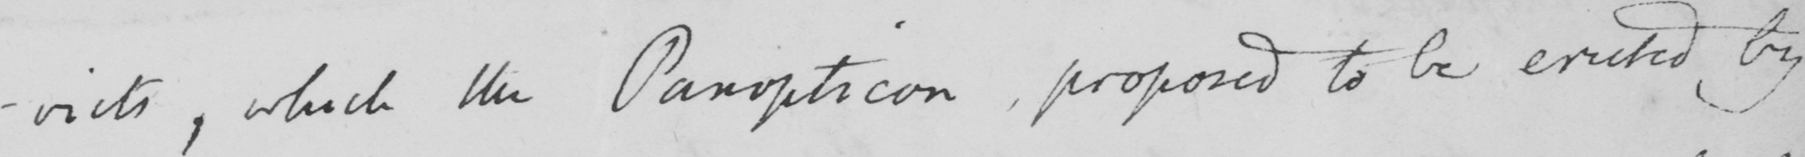What text is written in this handwritten line? -victs, which the Panopticon proposed to be erected by 